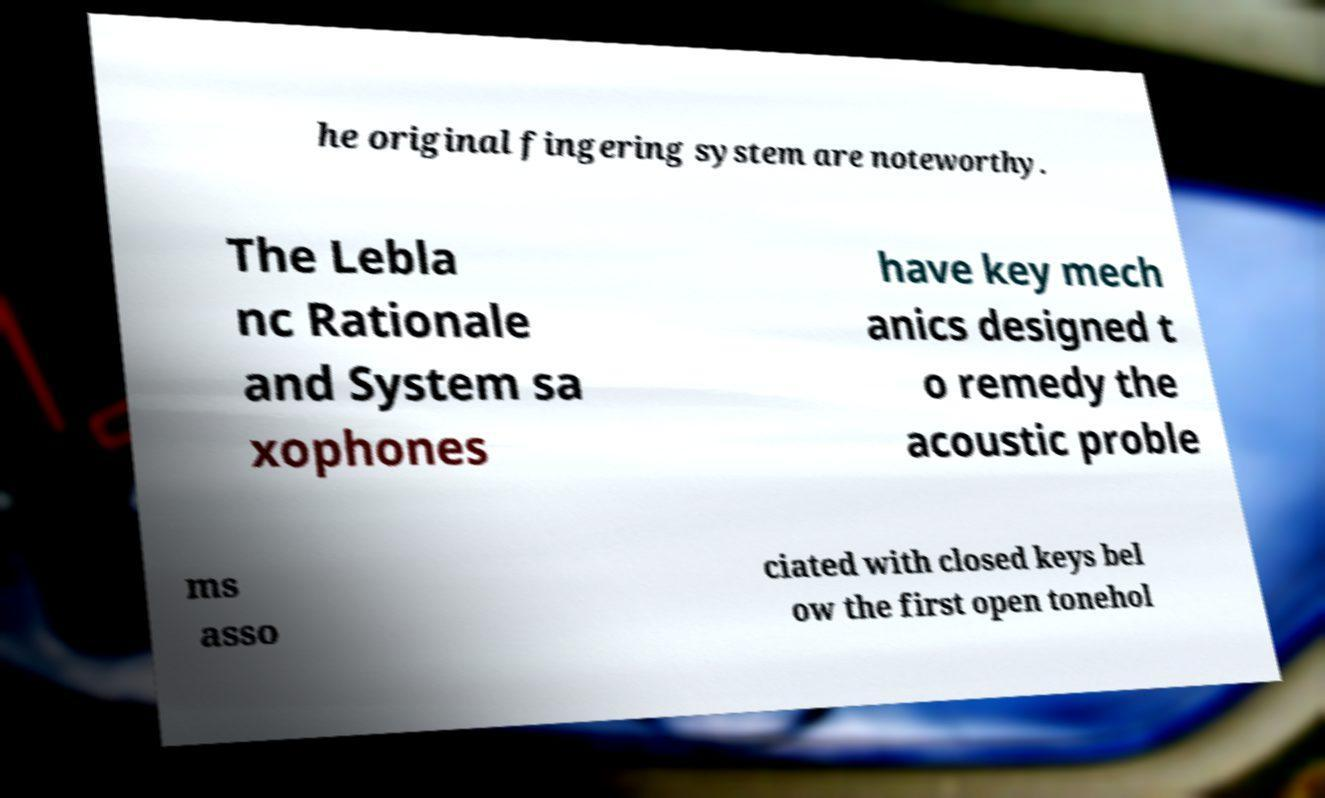Can you accurately transcribe the text from the provided image for me? he original fingering system are noteworthy. The Lebla nc Rationale and System sa xophones have key mech anics designed t o remedy the acoustic proble ms asso ciated with closed keys bel ow the first open tonehol 